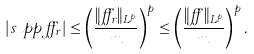<formula> <loc_0><loc_0><loc_500><loc_500>| s u p p \, \alpha _ { r } | \leq \left ( \frac { \| \alpha _ { r } \| _ { L ^ { p } } } { m } \right ) ^ { p } \leq \left ( \frac { \| \alpha \| _ { L ^ { p } } } { m } \right ) ^ { p } .</formula> 